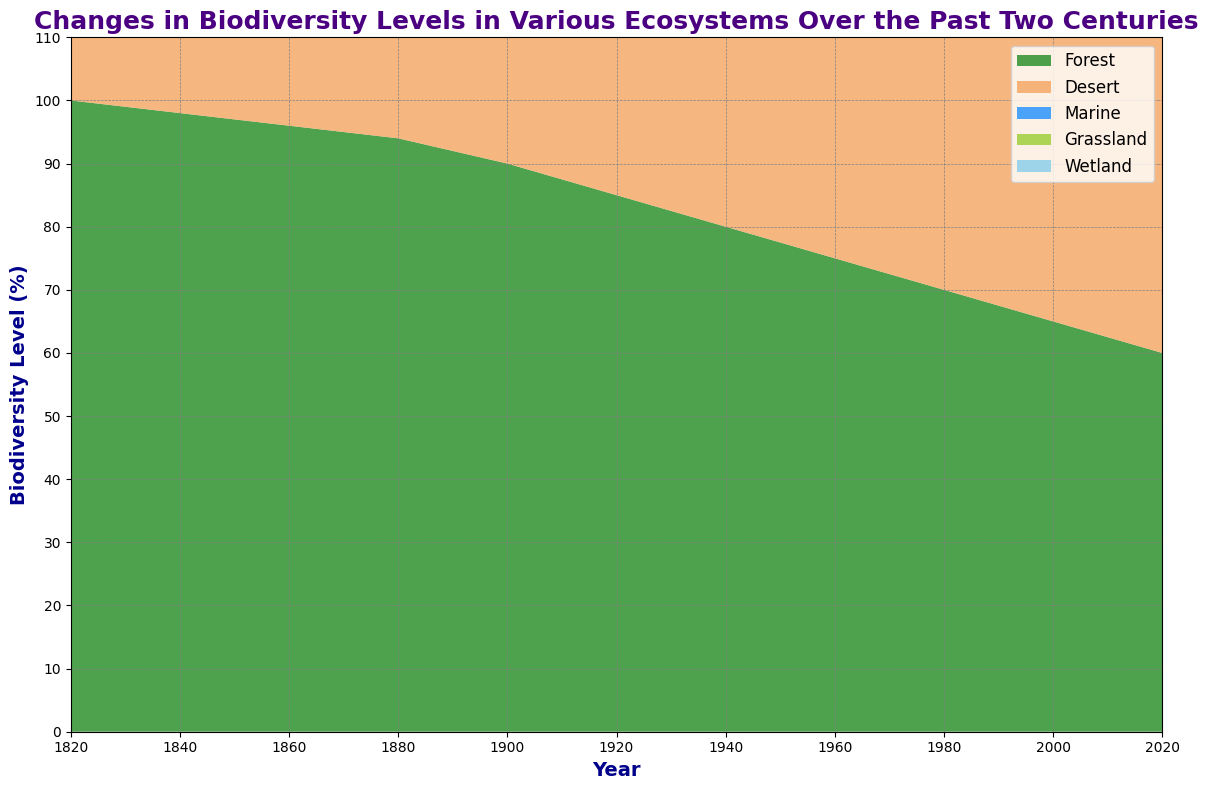How has forest biodiversity changed from 1820 to 2020? The forest biodiversity level started at 100% in 1820 and gradually declined to 60% by 2020.
Answer: It decreased by 40% Compare the biodiversity levels of marine and grassland ecosystems in 2000. In 2000, marine biodiversity was at 60%, while grassland biodiversity was at 55%. Both levels show significant decline but marine biodiversity is slightly higher.
Answer: Marine biodiversity is higher by 5% Which ecosystem experienced the smallest decline in biodiversity levels over the last 200 years? By comparing the initial and final biodiversity levels of all ecosystems, the desert ecosystem shows the smallest decline from 70% to 50%, a decrease of 20%.
Answer: Desert ecosystem Between 1920 and 1960, which ecosystem saw the largest percent decline in biodiversity? Forest biodiversity decreased from 85% to 75%, desert from 64% to 60%, marine from 75% to 65%, grassland from 72% to 65%, and wetland from 84% to 75%. The wetland ecosystem shows the largest decline of 12.5% (84 to 75).
Answer: Wetland ecosystem What was the average biodiversity level of the wetland ecosystem over the two centuries depicted? By summing the wetland biodiversity levels for each year (95 + 93 + 92 + 90 + 87 + 84 + 80 + 75 + 70 + 65 + 60) and dividing by the number of years (11), we get an average biodiversity level of approximately 80.
Answer: 80 In which time period did grassland biodiversity fall below 80% for the first time? Observing the grassland biodiversity levels, it fell below 80% between 1860 (80%) and 1880 (78%).
Answer: Between 1860 and 1880 Which ecosystems had biodiversity levels above 70% in 1920? Reviewing the data for 1920: forest (85), desert (64), marine (75), grassland (72), wetland (84), reveals that forest, marine, grassland, and wetland ecosystems were above 70%.
Answer: Forest, Marine, Grassland, Wetland How does the biodiversity trend of the marine ecosystem compare to the desert ecosystem over time? Both marine and desert biodiversity levels show a decreasing trend over time, but the marine ecosystem starts at a higher value (90%) compared to desert (70%) and maintains this higher value throughout.
Answer: Marine ecosystem is higher but both decrease What is the total decrease in biodiversity for the wetland ecosystem between 1820 and 2020? The wetland biodiversity level in 1820 was 95% and in 2020 it is 60%. The total decrease is 95 - 60 = 35%.
Answer: 35% Identify the ecosystem with the fastest decline between 1980 and 2000. By examining the two decades, marine biodiversity decreased from 62% to 60%, a decline of 2%; desert from 58% to 55%, a decline of 3%; grassland from 60% to 55%, a decline of 5%; wetland from 70% to 65%, a decline of 5%; and forest from 70% to 65%, a decline of 5%. Therefore, forest, grassland, and wetland ecosystems all show the fastest decline of 5%.
Answer: Forest, Grassland, Wetland (tie) 